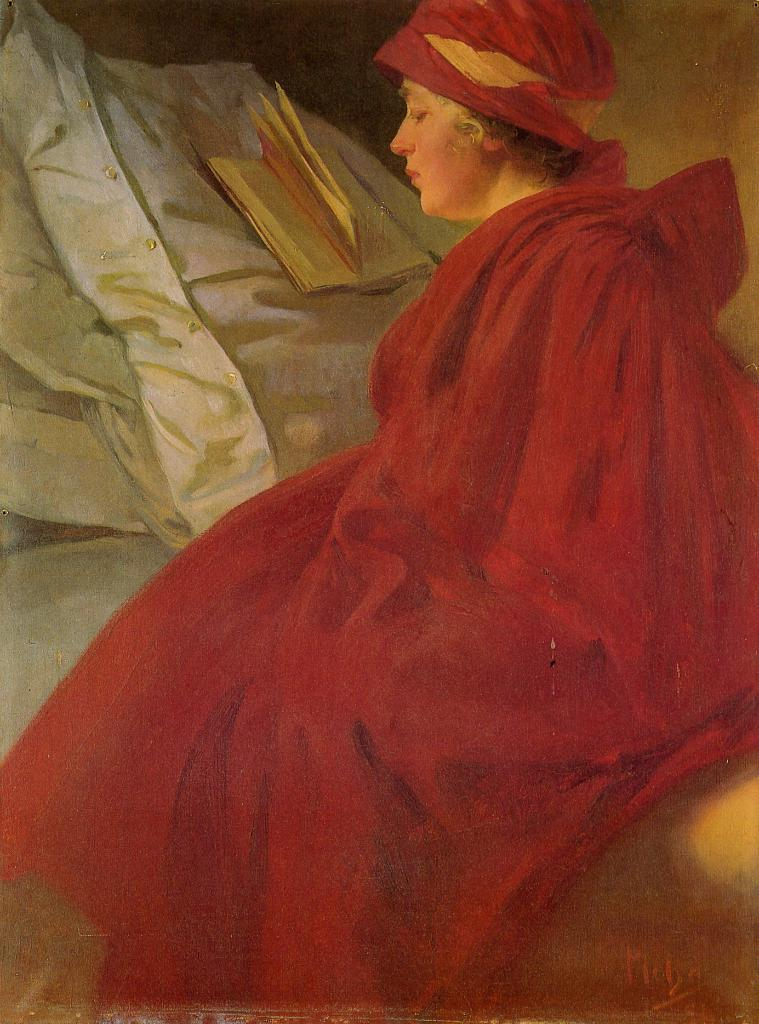Who is present in the image? There is a woman in the image. What is the woman doing in the image? The woman is sitting on the bed. What is the woman wearing in the image? The woman is wearing a red dress. What object can be seen on the bed in the image? There is a book placed on the bed. What can be seen in the background of the image? There is a wall in the background of the image. What unit of measurement is the woman using to measure the wall in the image? There is no indication in the image that the woman is measuring the wall or using any unit of measurement. 